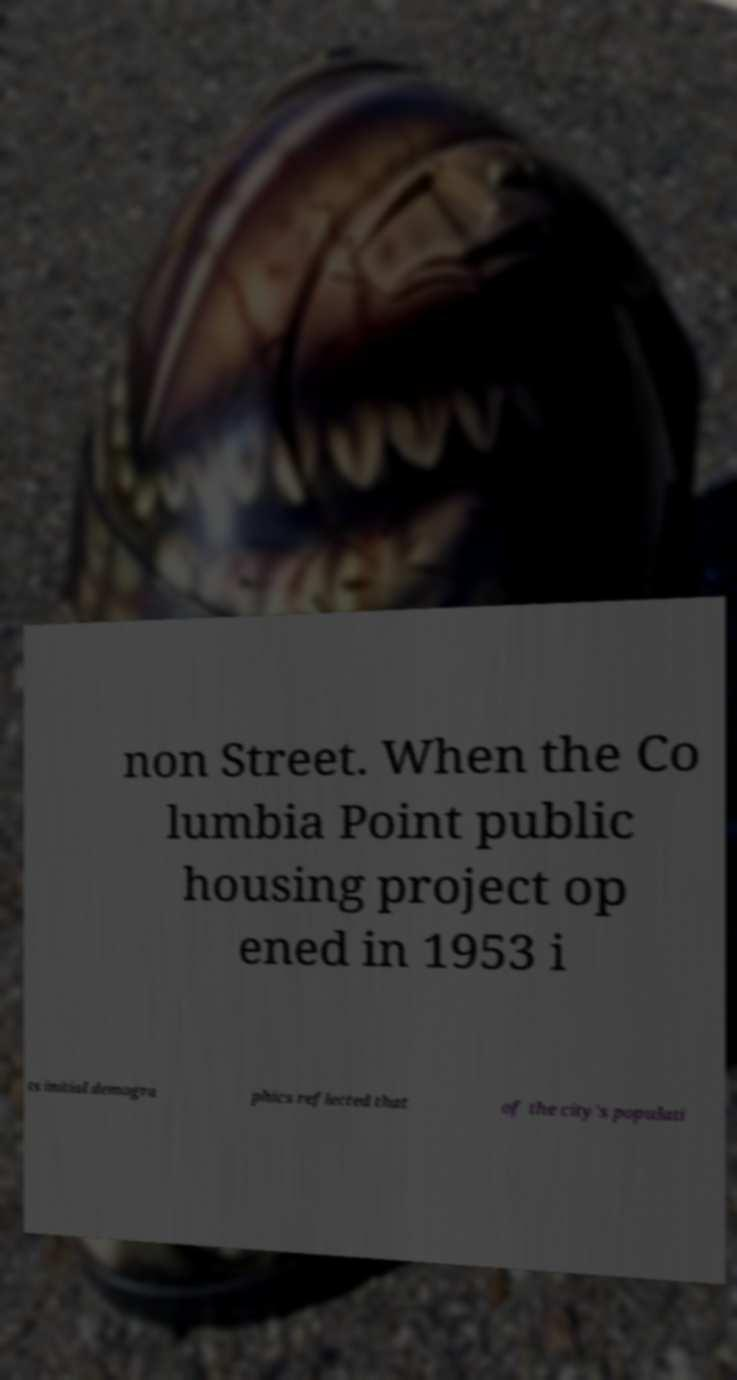Could you assist in decoding the text presented in this image and type it out clearly? non Street. When the Co lumbia Point public housing project op ened in 1953 i ts initial demogra phics reflected that of the city's populati 